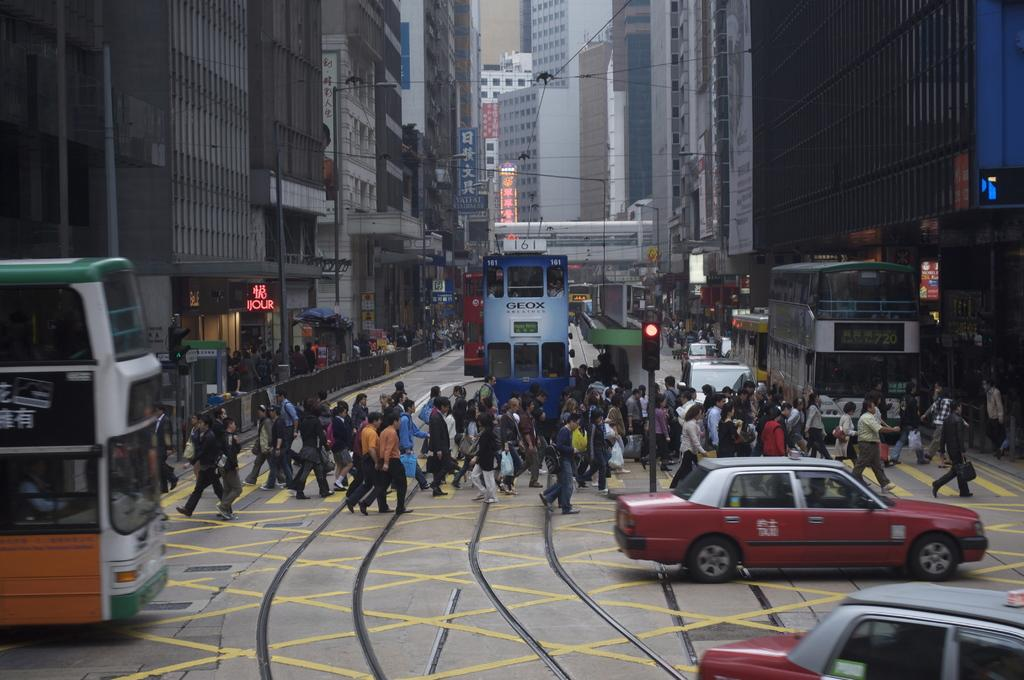Provide a one-sentence caption for the provided image. Streetcar 161 is on the street along with many pedestrians. 